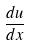Convert formula to latex. <formula><loc_0><loc_0><loc_500><loc_500>\frac { d u } { d x }</formula> 